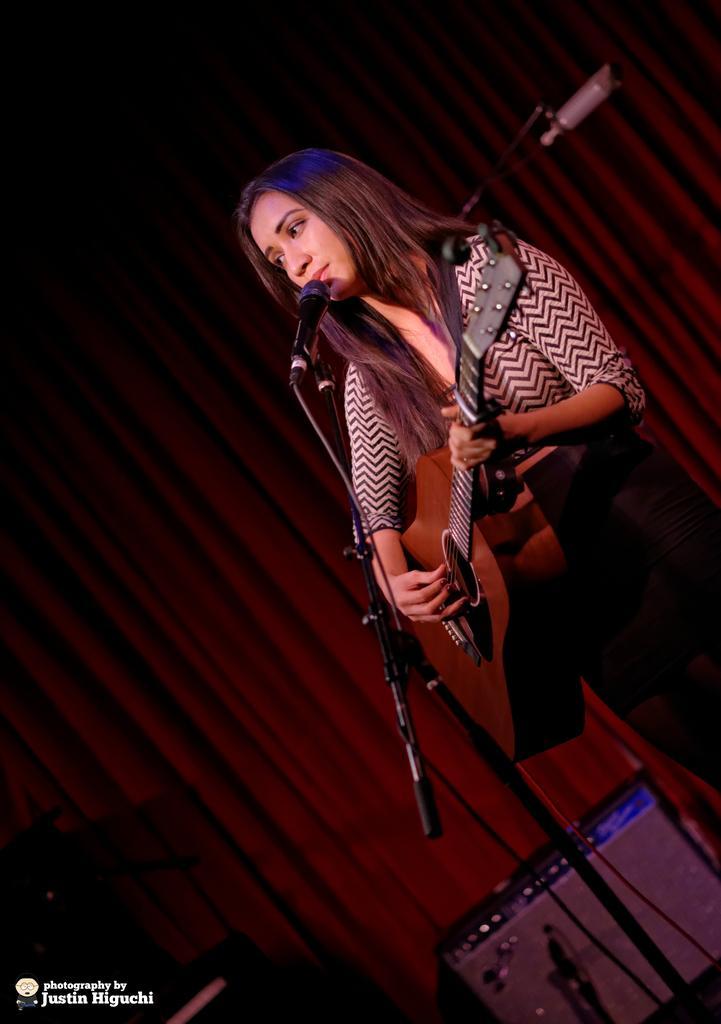How would you summarize this image in a sentence or two? In this image i can see a woman standing and playing guitar and singing in front a micro phone at the back ground i can see a curtain. 